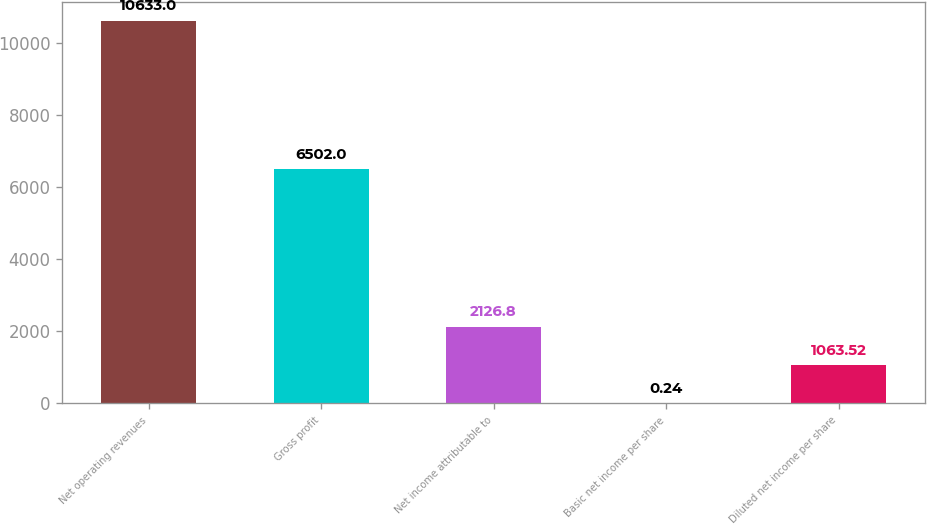Convert chart to OTSL. <chart><loc_0><loc_0><loc_500><loc_500><bar_chart><fcel>Net operating revenues<fcel>Gross profit<fcel>Net income attributable to<fcel>Basic net income per share<fcel>Diluted net income per share<nl><fcel>10633<fcel>6502<fcel>2126.8<fcel>0.24<fcel>1063.52<nl></chart> 